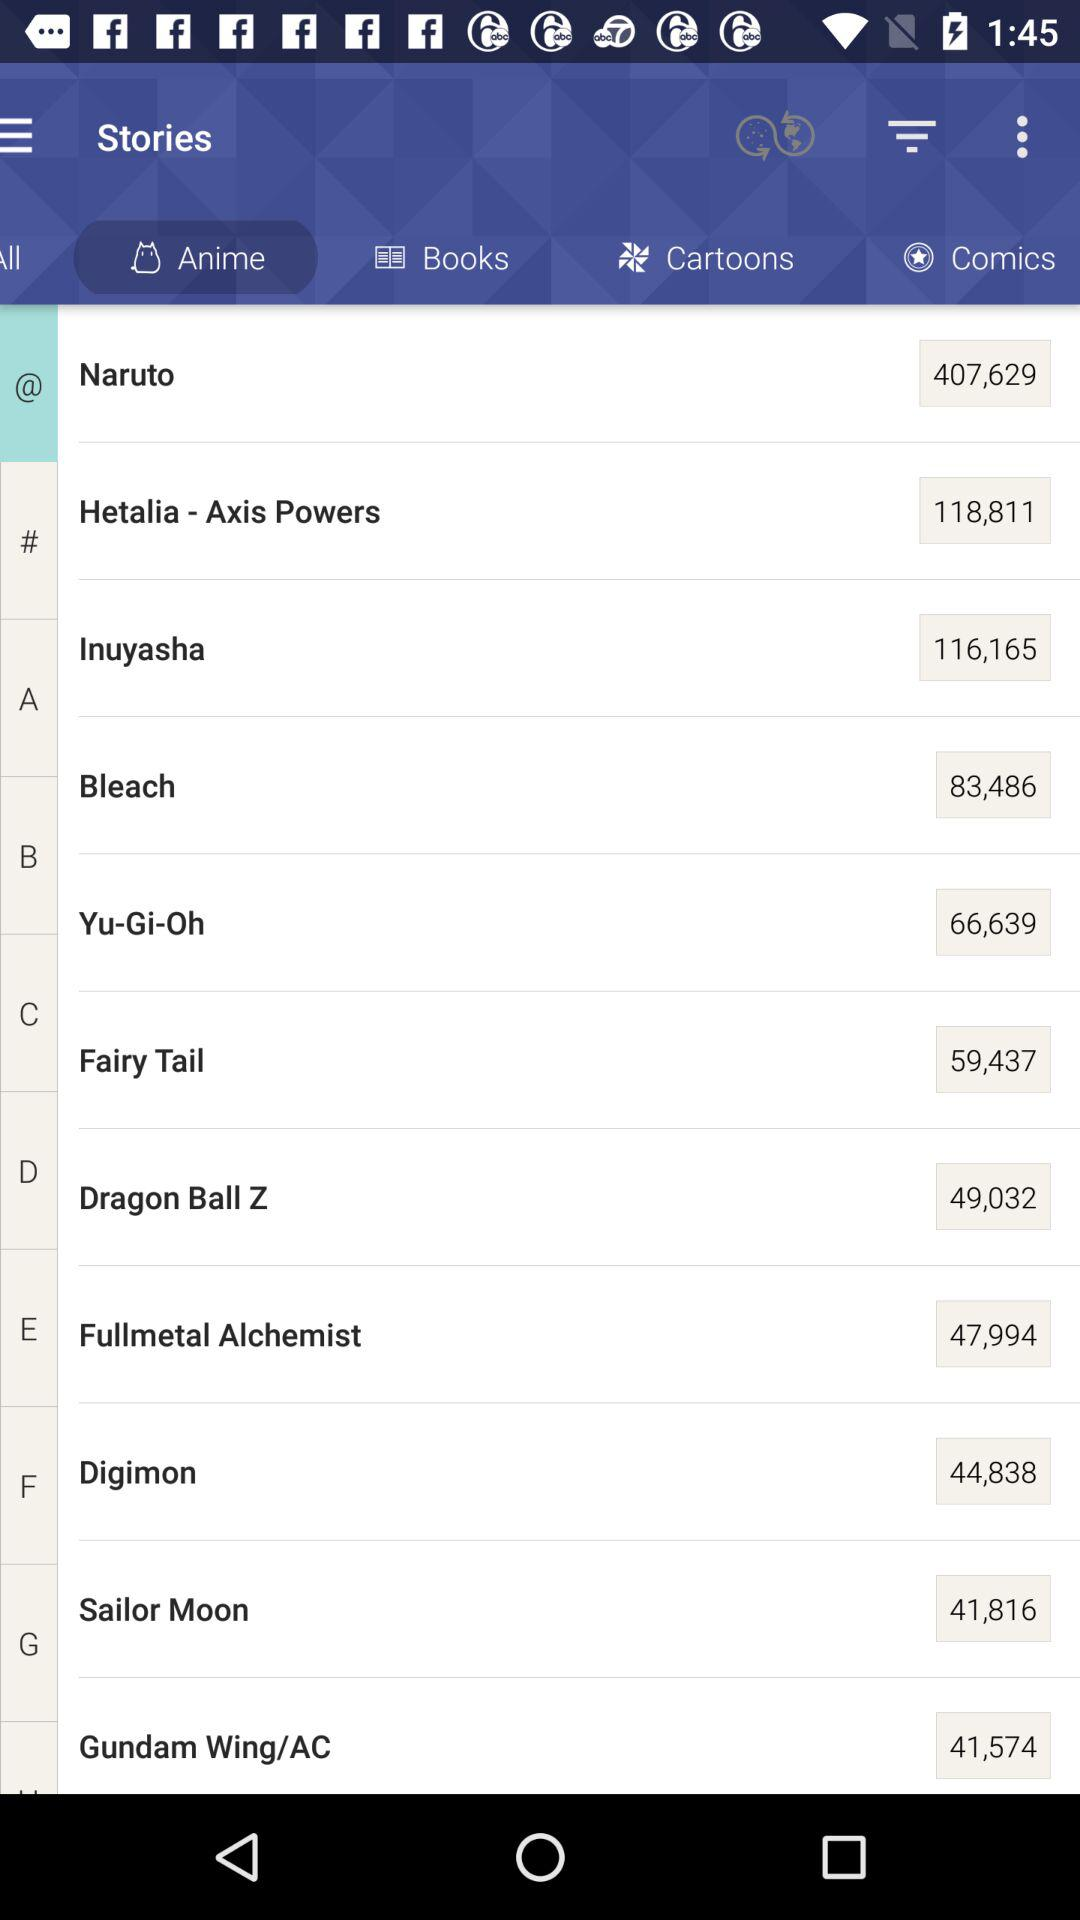Which tab is selected? The selected tab is "Anime". 